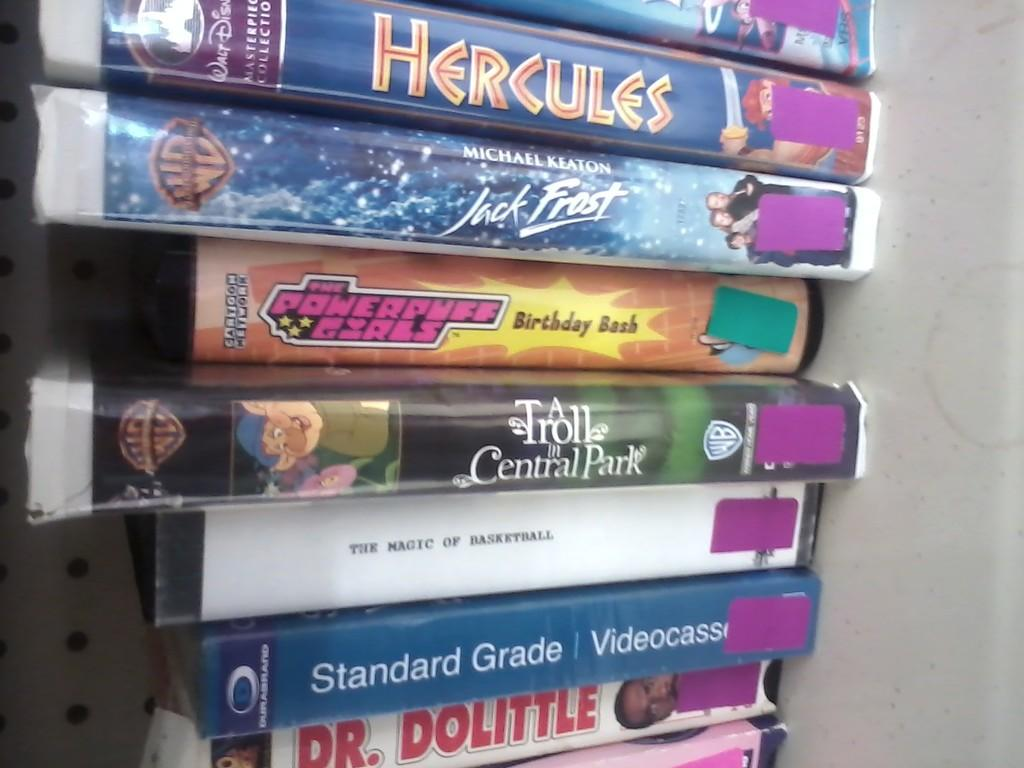<image>
Offer a succinct explanation of the picture presented. A stack of movies includes Dr. Dolittle and Hercules. 